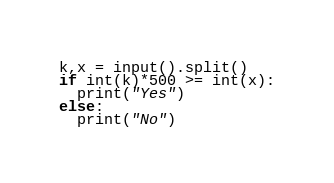Convert code to text. <code><loc_0><loc_0><loc_500><loc_500><_Python_>k,x = input().split()
if int(k)*500 >= int(x):
  print("Yes")
else:
  print("No")</code> 